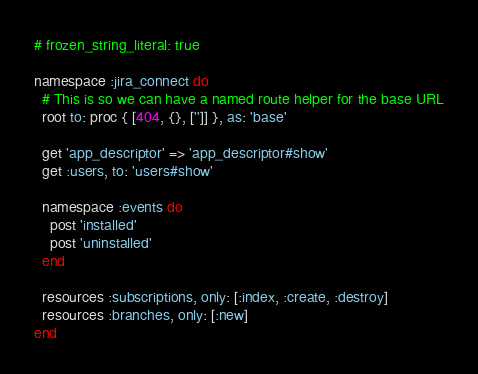<code> <loc_0><loc_0><loc_500><loc_500><_Ruby_># frozen_string_literal: true

namespace :jira_connect do
  # This is so we can have a named route helper for the base URL
  root to: proc { [404, {}, ['']] }, as: 'base'

  get 'app_descriptor' => 'app_descriptor#show'
  get :users, to: 'users#show'

  namespace :events do
    post 'installed'
    post 'uninstalled'
  end

  resources :subscriptions, only: [:index, :create, :destroy]
  resources :branches, only: [:new]
end
</code> 